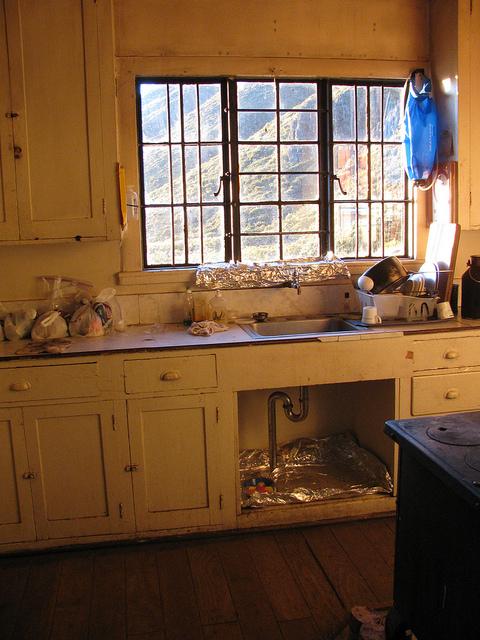What color are the cabinets?
Be succinct. White. What color bag is hanging by the window?
Quick response, please. Blue. What is located on the right door, lower part?
Quick response, please. Sink. Is this a kitchen?
Be succinct. Yes. What is on the window-sill?
Short answer required. Glasses. What is that shiny thing above the sink?
Short answer required. Window. Are those hand towels hanging up?
Write a very short answer. No. Do you see a star?
Be succinct. No. What is under the sink?
Answer briefly. Pipe. 